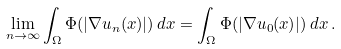<formula> <loc_0><loc_0><loc_500><loc_500>\lim _ { n \rightarrow \infty } \int _ { \Omega } \Phi ( | \nabla u _ { n } ( x ) | ) \, d x = \int _ { \Omega } \Phi ( | \nabla u _ { 0 } ( x ) | ) \, d x \, .</formula> 